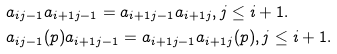Convert formula to latex. <formula><loc_0><loc_0><loc_500><loc_500>& a _ { i j - 1 } a _ { i + 1 j - 1 } = a _ { i + 1 j - 1 } a _ { i + 1 j } , j \leq i + 1 . \\ & a _ { i j - 1 } ( p ) a _ { i + 1 j - 1 } = a _ { i + 1 j - 1 } a _ { i + 1 j } ( p ) , j \leq i + 1 .</formula> 